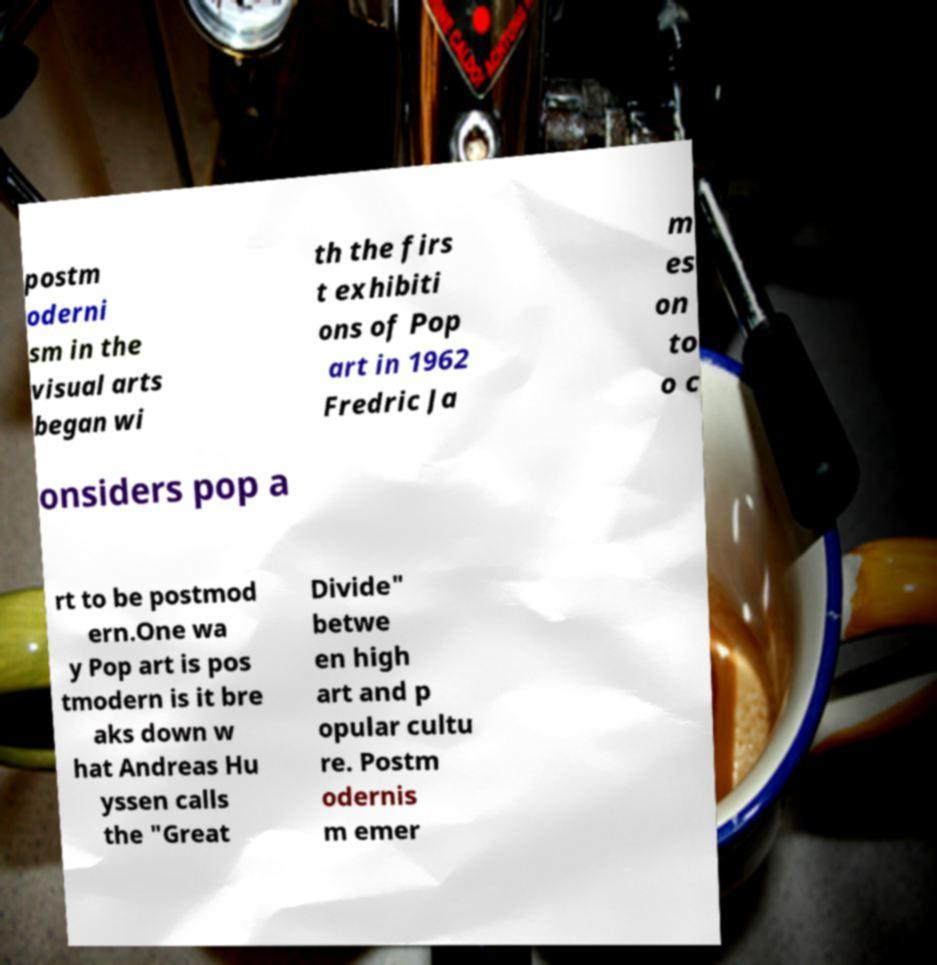Please identify and transcribe the text found in this image. postm oderni sm in the visual arts began wi th the firs t exhibiti ons of Pop art in 1962 Fredric Ja m es on to o c onsiders pop a rt to be postmod ern.One wa y Pop art is pos tmodern is it bre aks down w hat Andreas Hu yssen calls the "Great Divide" betwe en high art and p opular cultu re. Postm odernis m emer 